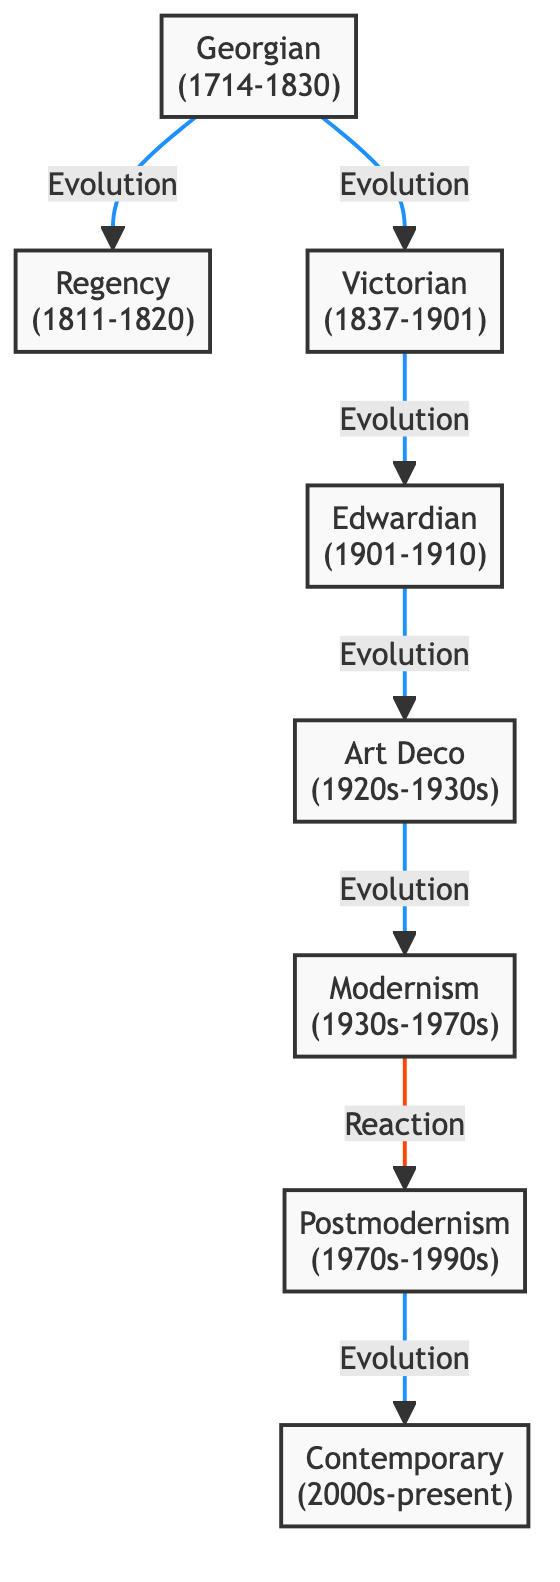What is the period of the Edwardian architectural style? The period of Edwardian architecture is given in the diagram as 1901-1910, which can be found next to the Edwardian node.
Answer: 1901-1910 How many architectural styles are depicted in the diagram? By counting the nodes in the diagram, we see there are eight distinct architectural styles ranging from Georgian to Contemporary.
Answer: 8 What is the relationship between Modernism and Postmodernism? The diagram describes the relationship as a "reaction," indicated by the different colors of the connecting line, specifically the red one connecting Modernism to Postmodernism.
Answer: Reaction Which architectural style follows directly after Victorian? The next node directly connected to Victorian is Edwardian, as indicated by the arrow pointing from Victorian to Edwardian.
Answer: Edwardian How does Art Deco relate to Edwardian architecture? The diagram illustrates that Art Deco follows Edwardian architecture, as shown by an arrow indicating an "evolution" relationship from Edwardian to Art Deco.
Answer: Evolution Which architectural style is characterized by minimalism and functionalism? Modernism is the style associated with minimalism and functionalism, as described in the explanation next to the Modernism node.
Answer: Modernism What type of link connects Georgian architecture to Regency architecture? The link connecting Georgian to Regency architecture is labeled as "evolution," which is shown alongside the arrow connecting the two nodes.
Answer: Evolution What is the earliest architectural style mentioned in the diagram? The earliest architectural style indicated in the diagram is Georgian, which is listed as the first node, corresponding to the historical period of 1714-1830.
Answer: Georgian 